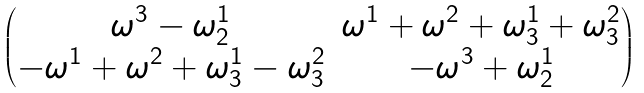<formula> <loc_0><loc_0><loc_500><loc_500>\begin{pmatrix} \omega ^ { 3 } - \omega _ { 2 } ^ { 1 } & \omega ^ { 1 } + \omega ^ { 2 } + \omega _ { 3 } ^ { 1 } + \omega _ { 3 } ^ { 2 } \\ - \omega ^ { 1 } + \omega ^ { 2 } + \omega _ { 3 } ^ { 1 } - \omega _ { 3 } ^ { 2 } & - \omega ^ { 3 } + \omega _ { 2 } ^ { 1 } \end{pmatrix}</formula> 